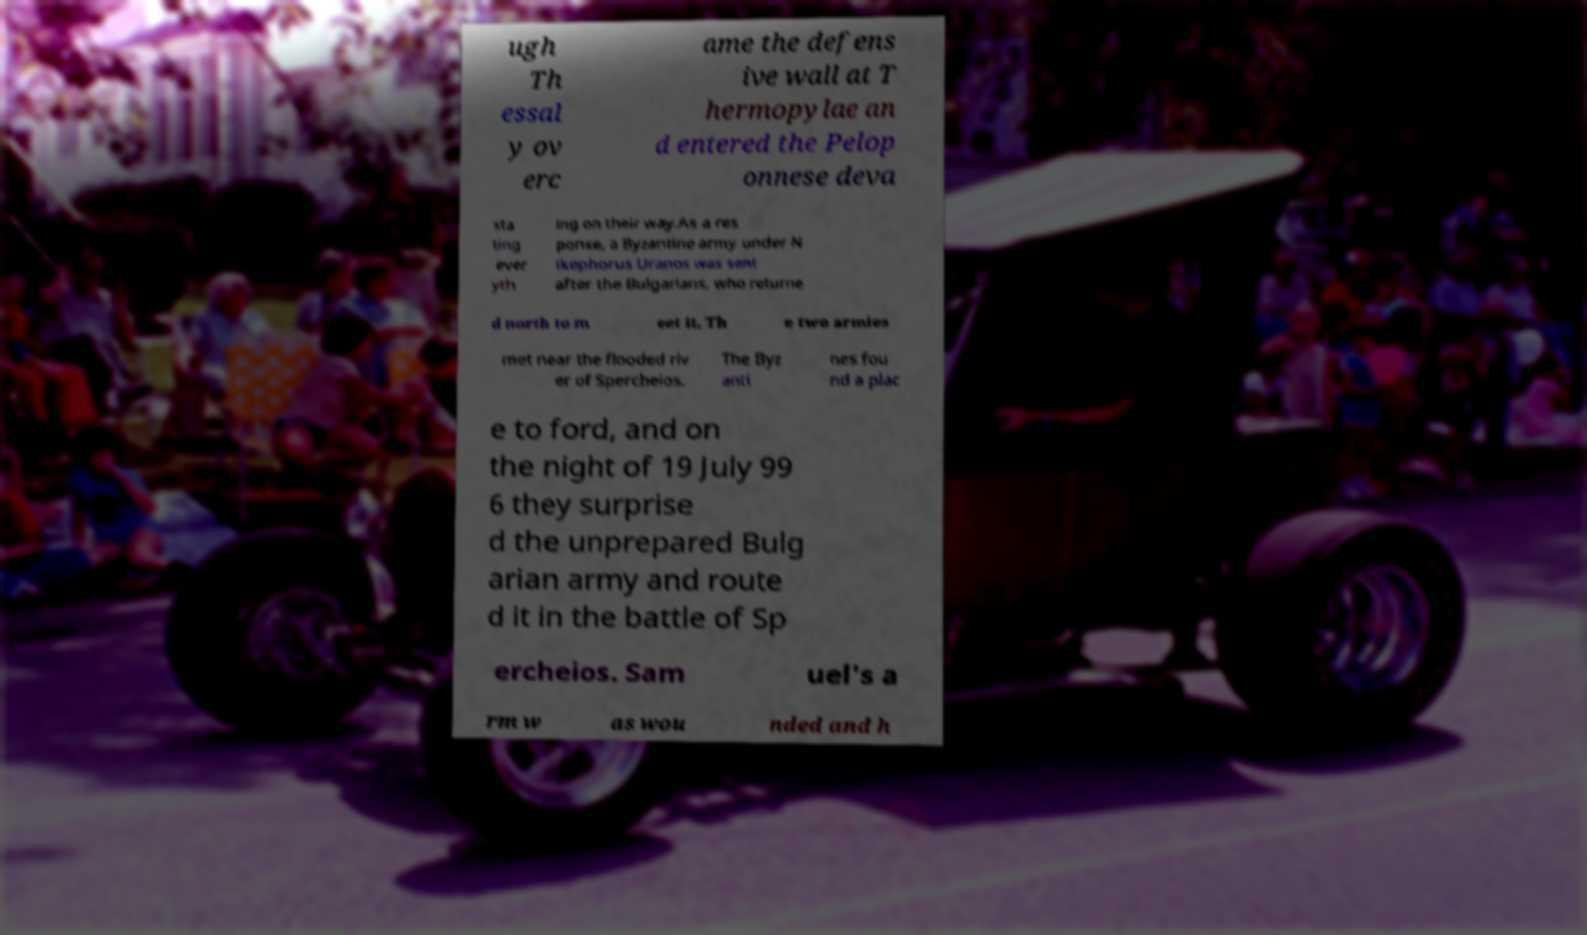Can you read and provide the text displayed in the image?This photo seems to have some interesting text. Can you extract and type it out for me? ugh Th essal y ov erc ame the defens ive wall at T hermopylae an d entered the Pelop onnese deva sta ting ever yth ing on their way.As a res ponse, a Byzantine army under N ikephorus Uranos was sent after the Bulgarians, who returne d north to m eet it. Th e two armies met near the flooded riv er of Spercheios. The Byz anti nes fou nd a plac e to ford, and on the night of 19 July 99 6 they surprise d the unprepared Bulg arian army and route d it in the battle of Sp ercheios. Sam uel's a rm w as wou nded and h 